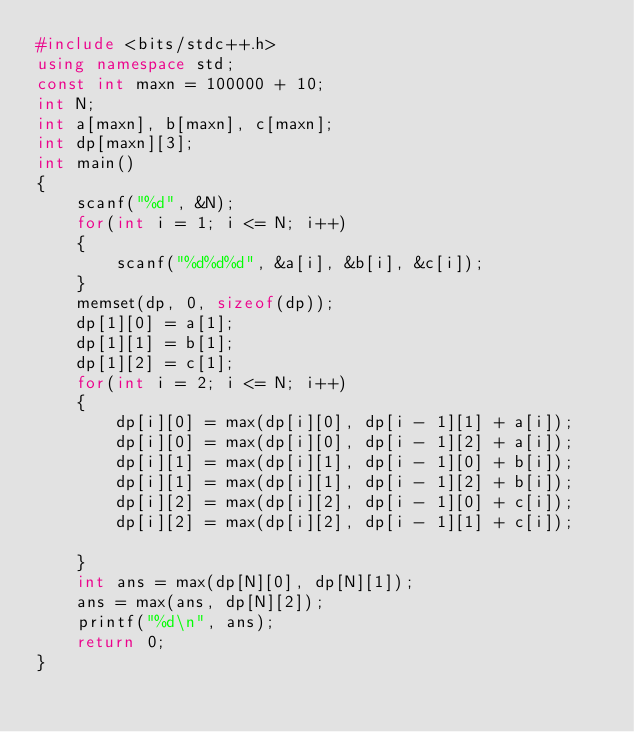Convert code to text. <code><loc_0><loc_0><loc_500><loc_500><_C++_>#include <bits/stdc++.h>
using namespace std;
const int maxn = 100000 + 10;
int N;
int a[maxn], b[maxn], c[maxn];
int dp[maxn][3];
int main()
{
    scanf("%d", &N);
    for(int i = 1; i <= N; i++)
    {
        scanf("%d%d%d", &a[i], &b[i], &c[i]);
    }
    memset(dp, 0, sizeof(dp));
    dp[1][0] = a[1];
    dp[1][1] = b[1];
    dp[1][2] = c[1];
    for(int i = 2; i <= N; i++)
    {
        dp[i][0] = max(dp[i][0], dp[i - 1][1] + a[i]);
        dp[i][0] = max(dp[i][0], dp[i - 1][2] + a[i]);
        dp[i][1] = max(dp[i][1], dp[i - 1][0] + b[i]);
        dp[i][1] = max(dp[i][1], dp[i - 1][2] + b[i]);
        dp[i][2] = max(dp[i][2], dp[i - 1][0] + c[i]);
        dp[i][2] = max(dp[i][2], dp[i - 1][1] + c[i]);

    }
    int ans = max(dp[N][0], dp[N][1]);
    ans = max(ans, dp[N][2]);
    printf("%d\n", ans);
    return 0;
}
</code> 